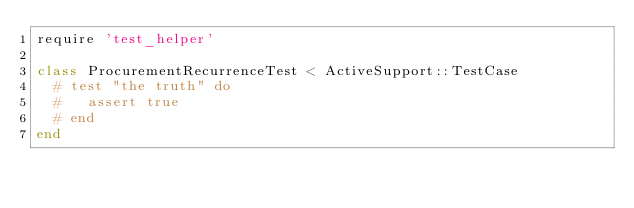<code> <loc_0><loc_0><loc_500><loc_500><_Ruby_>require 'test_helper'

class ProcurementRecurrenceTest < ActiveSupport::TestCase
  # test "the truth" do
  #   assert true
  # end
end
</code> 